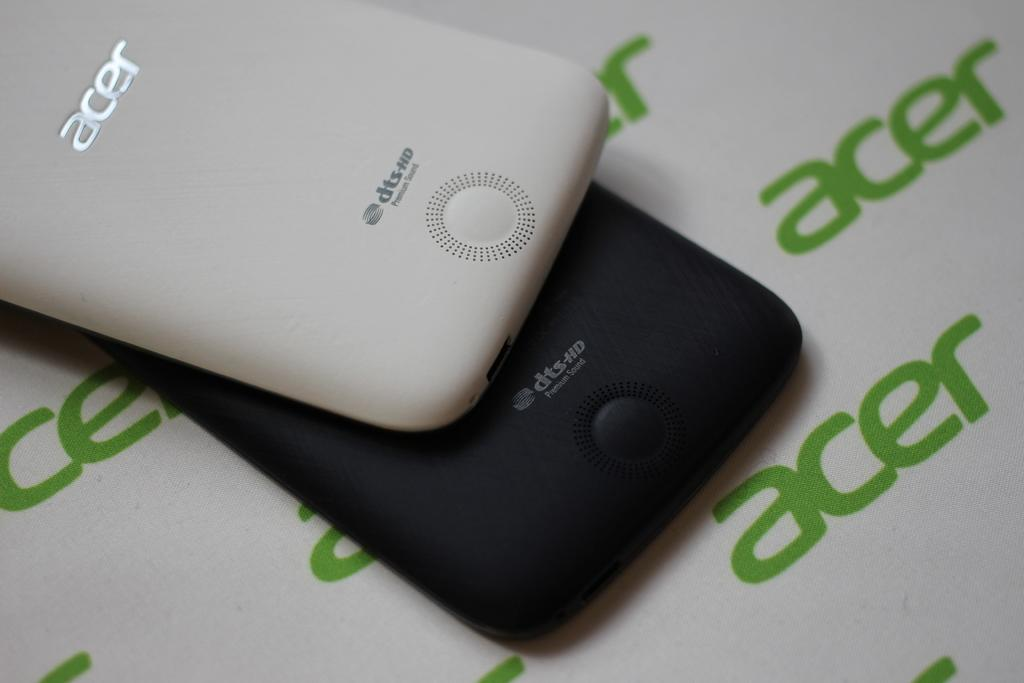<image>
Relay a brief, clear account of the picture shown. Two Acer branded cell phones sitting on top of one another. 